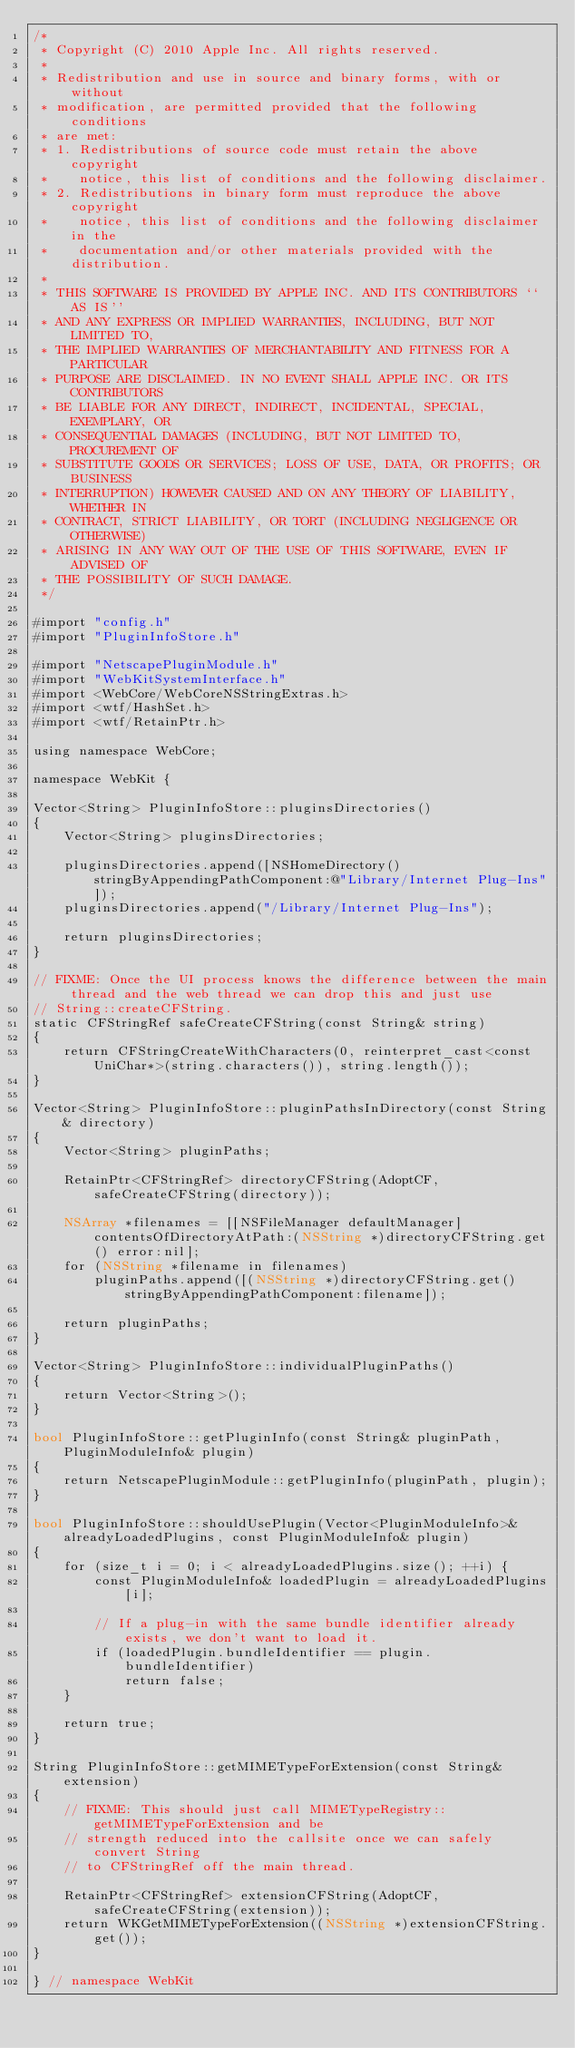Convert code to text. <code><loc_0><loc_0><loc_500><loc_500><_ObjectiveC_>/*
 * Copyright (C) 2010 Apple Inc. All rights reserved.
 *
 * Redistribution and use in source and binary forms, with or without
 * modification, are permitted provided that the following conditions
 * are met:
 * 1. Redistributions of source code must retain the above copyright
 *    notice, this list of conditions and the following disclaimer.
 * 2. Redistributions in binary form must reproduce the above copyright
 *    notice, this list of conditions and the following disclaimer in the
 *    documentation and/or other materials provided with the distribution.
 *
 * THIS SOFTWARE IS PROVIDED BY APPLE INC. AND ITS CONTRIBUTORS ``AS IS''
 * AND ANY EXPRESS OR IMPLIED WARRANTIES, INCLUDING, BUT NOT LIMITED TO,
 * THE IMPLIED WARRANTIES OF MERCHANTABILITY AND FITNESS FOR A PARTICULAR
 * PURPOSE ARE DISCLAIMED. IN NO EVENT SHALL APPLE INC. OR ITS CONTRIBUTORS
 * BE LIABLE FOR ANY DIRECT, INDIRECT, INCIDENTAL, SPECIAL, EXEMPLARY, OR
 * CONSEQUENTIAL DAMAGES (INCLUDING, BUT NOT LIMITED TO, PROCUREMENT OF
 * SUBSTITUTE GOODS OR SERVICES; LOSS OF USE, DATA, OR PROFITS; OR BUSINESS
 * INTERRUPTION) HOWEVER CAUSED AND ON ANY THEORY OF LIABILITY, WHETHER IN
 * CONTRACT, STRICT LIABILITY, OR TORT (INCLUDING NEGLIGENCE OR OTHERWISE)
 * ARISING IN ANY WAY OUT OF THE USE OF THIS SOFTWARE, EVEN IF ADVISED OF
 * THE POSSIBILITY OF SUCH DAMAGE.
 */

#import "config.h"
#import "PluginInfoStore.h"

#import "NetscapePluginModule.h"
#import "WebKitSystemInterface.h"
#import <WebCore/WebCoreNSStringExtras.h>
#import <wtf/HashSet.h>
#import <wtf/RetainPtr.h>

using namespace WebCore;

namespace WebKit {

Vector<String> PluginInfoStore::pluginsDirectories()
{
    Vector<String> pluginsDirectories;

    pluginsDirectories.append([NSHomeDirectory() stringByAppendingPathComponent:@"Library/Internet Plug-Ins"]);
    pluginsDirectories.append("/Library/Internet Plug-Ins");
    
    return pluginsDirectories;
}

// FIXME: Once the UI process knows the difference between the main thread and the web thread we can drop this and just use
// String::createCFString.
static CFStringRef safeCreateCFString(const String& string)
{
    return CFStringCreateWithCharacters(0, reinterpret_cast<const UniChar*>(string.characters()), string.length());
}
    
Vector<String> PluginInfoStore::pluginPathsInDirectory(const String& directory)
{
    Vector<String> pluginPaths;

    RetainPtr<CFStringRef> directoryCFString(AdoptCF, safeCreateCFString(directory));
    
    NSArray *filenames = [[NSFileManager defaultManager] contentsOfDirectoryAtPath:(NSString *)directoryCFString.get() error:nil];
    for (NSString *filename in filenames)
        pluginPaths.append([(NSString *)directoryCFString.get() stringByAppendingPathComponent:filename]);
    
    return pluginPaths;
}

Vector<String> PluginInfoStore::individualPluginPaths()
{
    return Vector<String>();
}

bool PluginInfoStore::getPluginInfo(const String& pluginPath, PluginModuleInfo& plugin)
{
    return NetscapePluginModule::getPluginInfo(pluginPath, plugin);
}

bool PluginInfoStore::shouldUsePlugin(Vector<PluginModuleInfo>& alreadyLoadedPlugins, const PluginModuleInfo& plugin)
{
    for (size_t i = 0; i < alreadyLoadedPlugins.size(); ++i) {
        const PluginModuleInfo& loadedPlugin = alreadyLoadedPlugins[i];

        // If a plug-in with the same bundle identifier already exists, we don't want to load it.
        if (loadedPlugin.bundleIdentifier == plugin.bundleIdentifier)
            return false;
    }

    return true;
}

String PluginInfoStore::getMIMETypeForExtension(const String& extension)
{
    // FIXME: This should just call MIMETypeRegistry::getMIMETypeForExtension and be
    // strength reduced into the callsite once we can safely convert String
    // to CFStringRef off the main thread.

    RetainPtr<CFStringRef> extensionCFString(AdoptCF, safeCreateCFString(extension));
    return WKGetMIMETypeForExtension((NSString *)extensionCFString.get());
}

} // namespace WebKit
</code> 